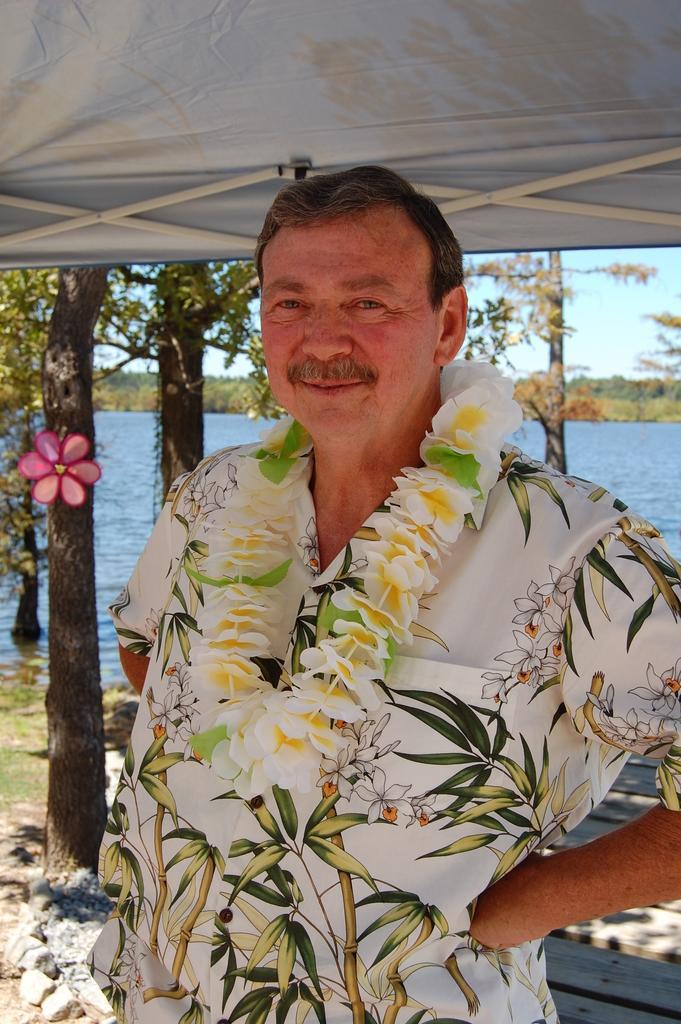Please provide a concise description of this image. In this image I can see a person is wearing a garland is standing on the ground. In the background I can see water, tent, trees, grass, stones and the sky. This image is taken may be near the lake. 